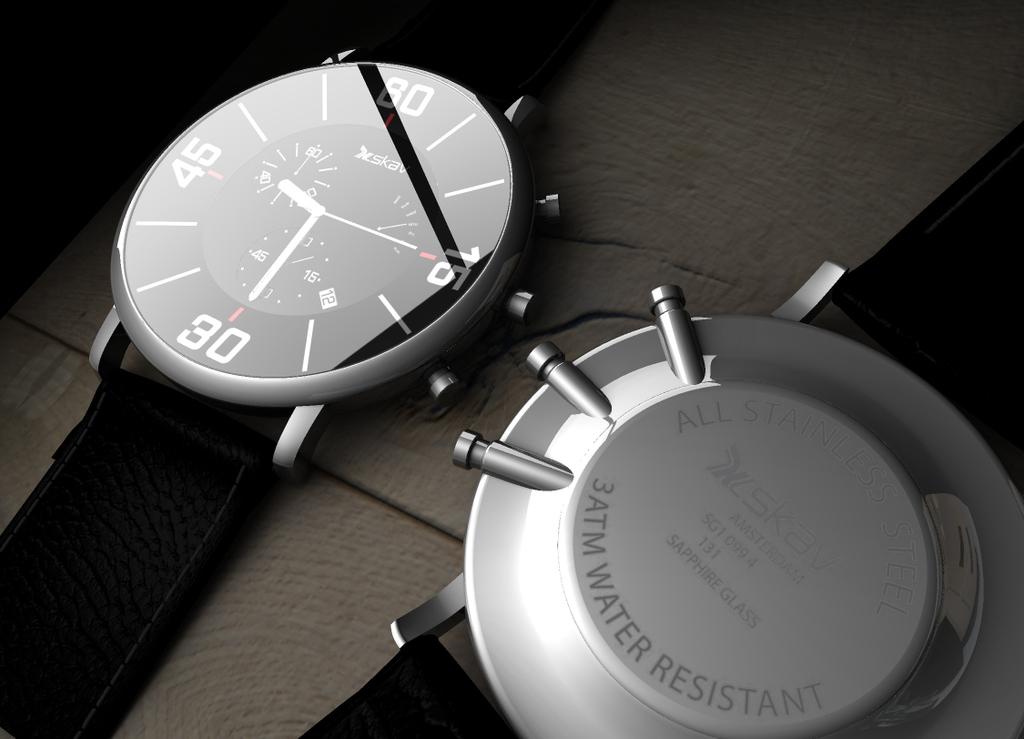How water resistant is this watch?
Make the answer very short. 3atm. What metal is this watch made from?
Ensure brevity in your answer.  Stainless steel. 